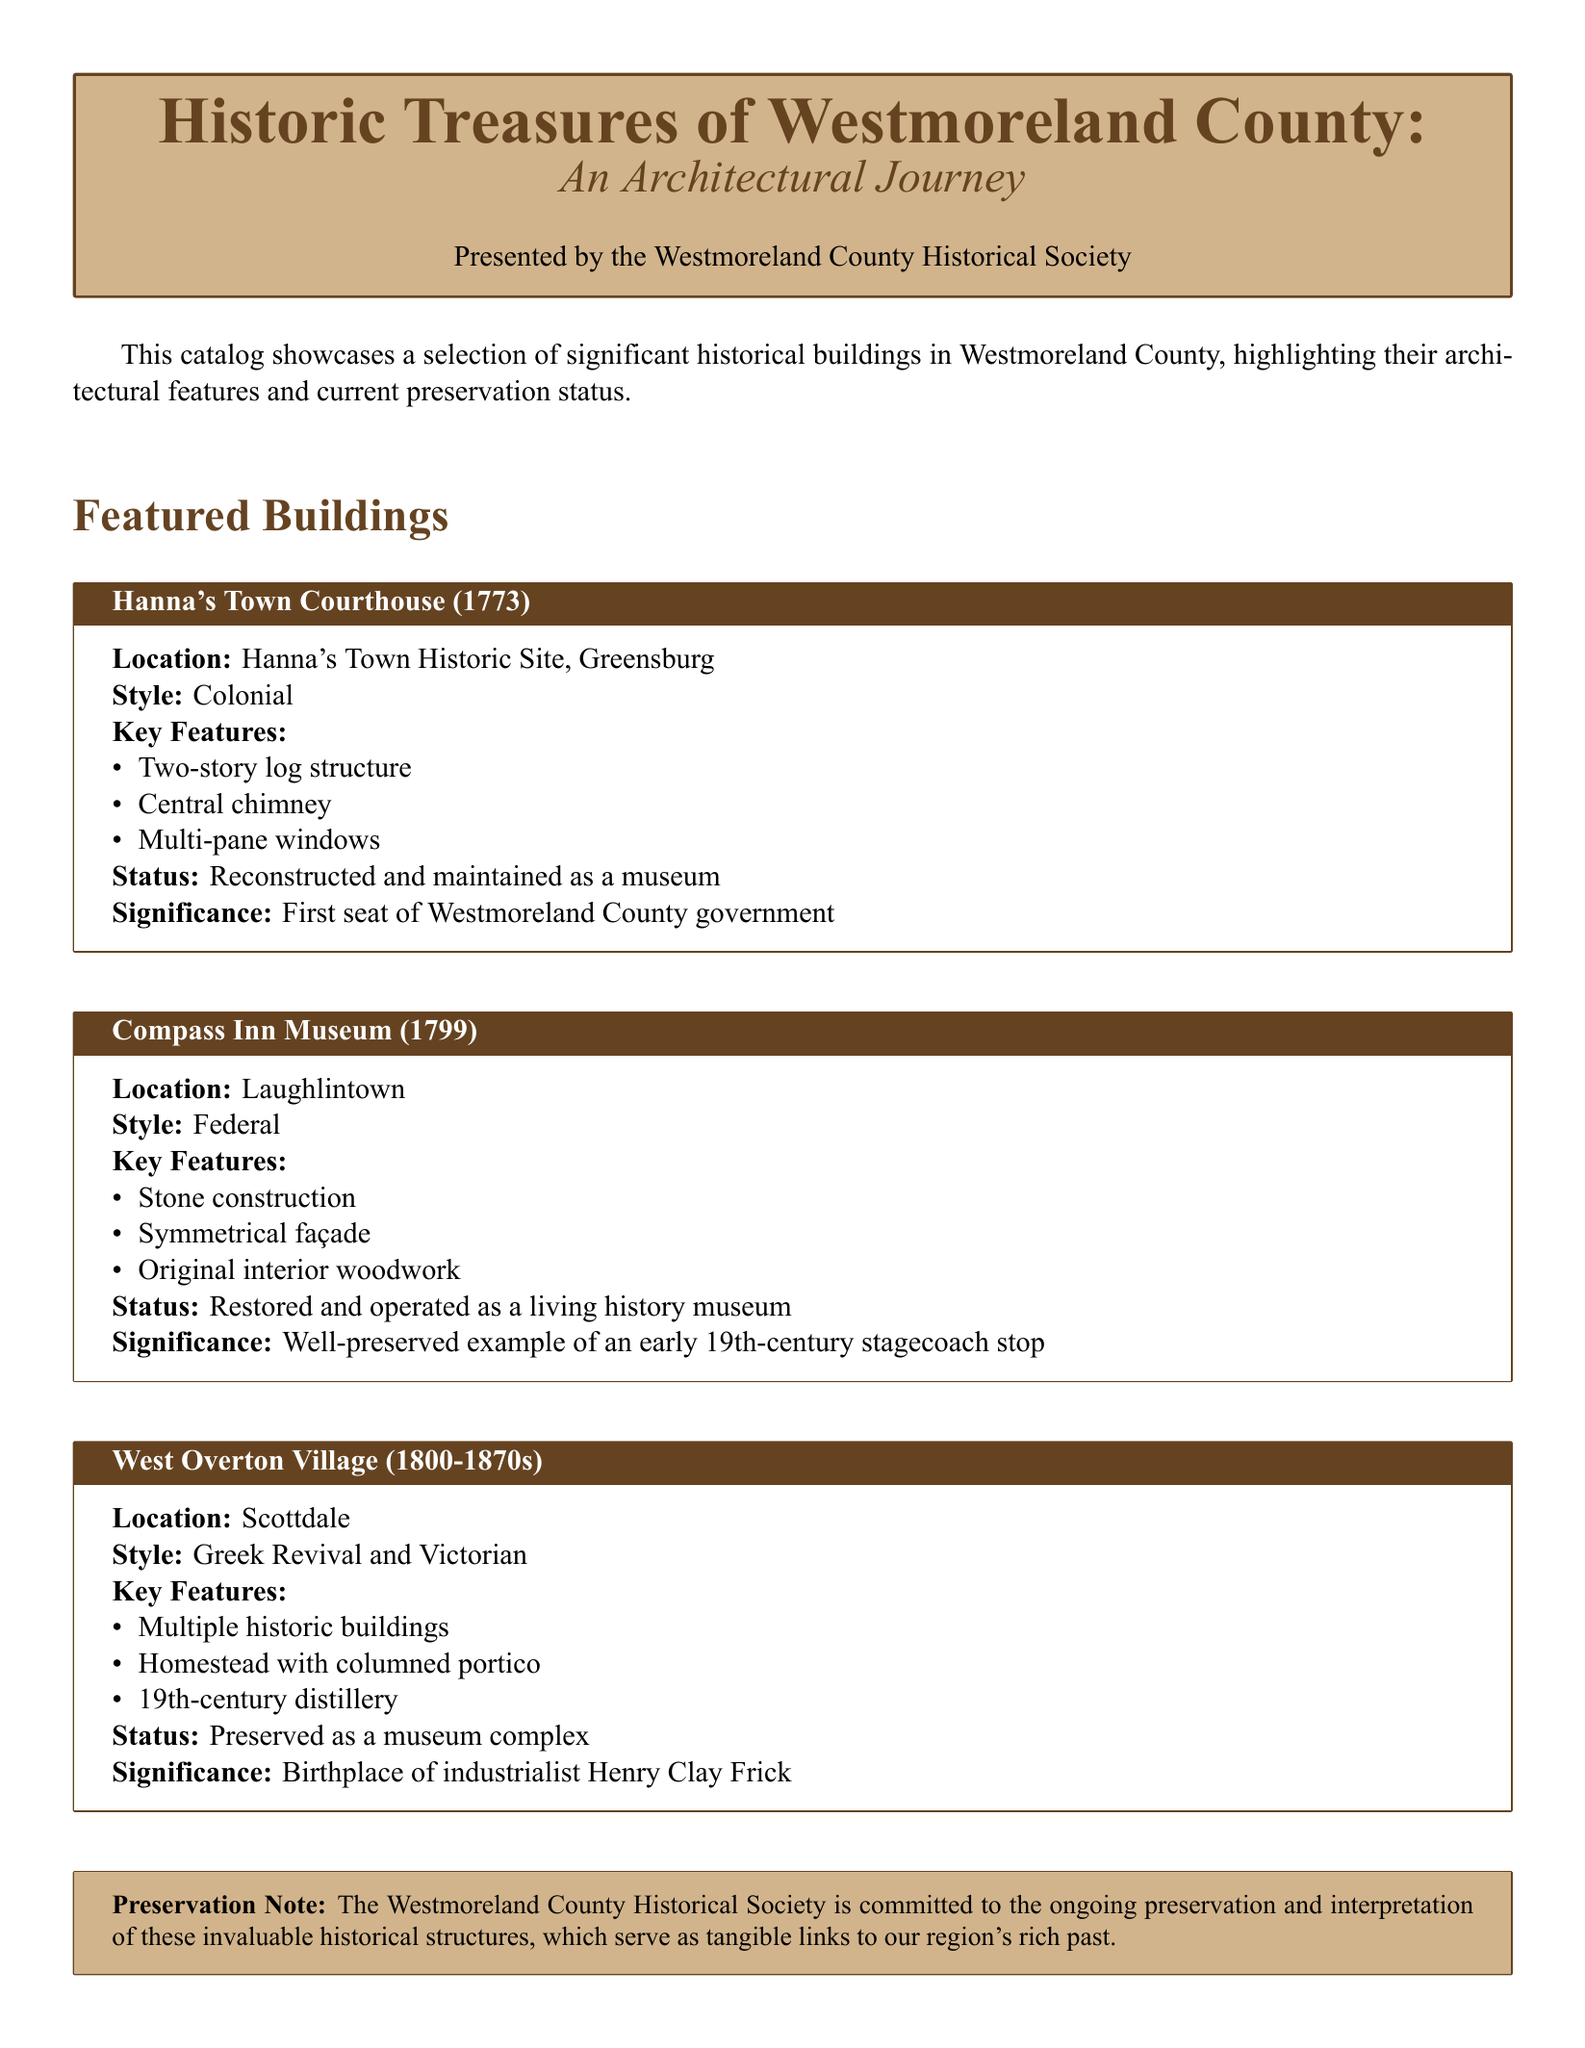What is the location of Hanna's Town Courthouse? The location is provided under the featured building section for Hanna's Town Courthouse.
Answer: Hanna's Town Historic Site, Greensburg What year was the Compass Inn Museum built? The year is mentioned in the title of the featured building section for Compass Inn Museum.
Answer: 1799 What architectural style is West Overton Village? The style is described under the featured building section for West Overton Village.
Answer: Greek Revival and Victorian How many historic buildings are included in West Overton Village? This requires understanding that multiple historic buildings refer to the collection in the mentioned site.
Answer: Multiple What is the preservation status of Hanna's Town Courthouse? The status is given in the features of Hanna's Town Courthouse section.
Answer: Reconstructed and maintained as a museum What is the significance of West Overton Village? The significance is provided in its respective section and highlights its historical importance.
Answer: Birthplace of industrialist Henry Clay Frick Which building features original interior woodwork? The building containing original interior woodwork is explicitly mentioned in its key features.
Answer: Compass Inn Museum What color is used for the background of the preservation note box? The color can be inferred from the specified features of the preservation note in the document.
Answer: Light brown 